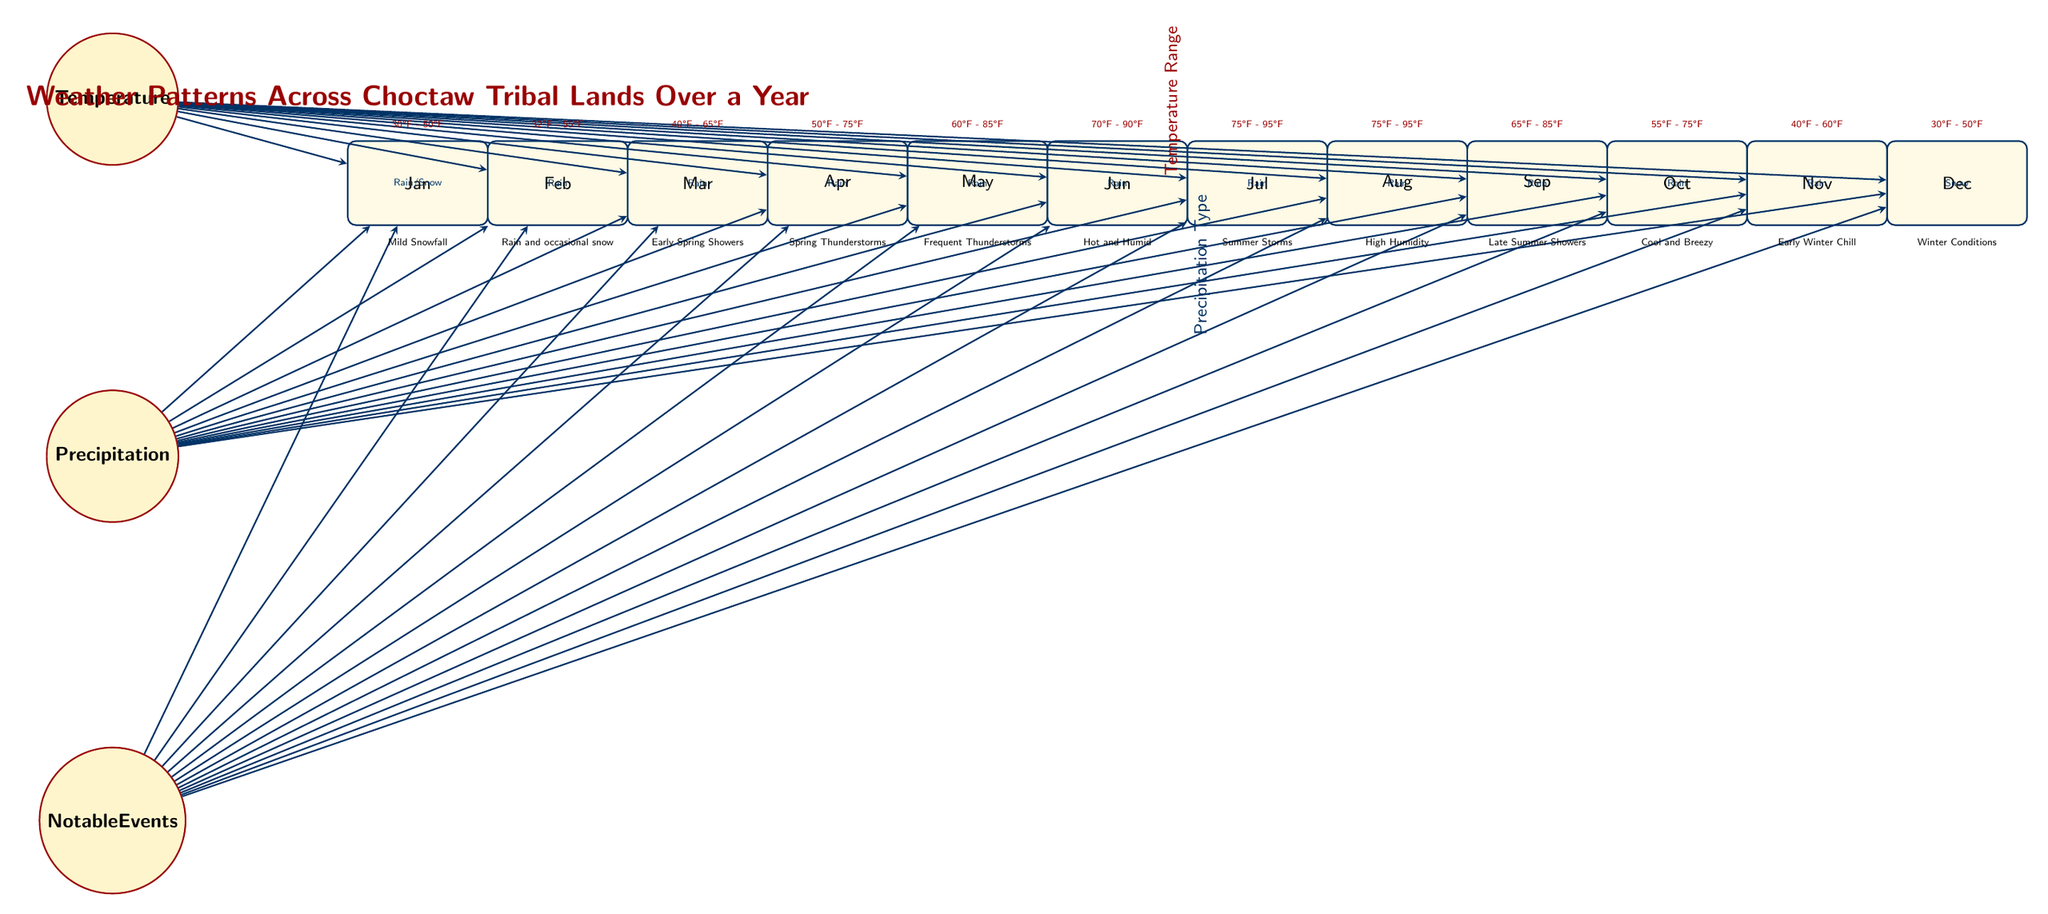What is the temperature range for July? To find the temperature range for July, locate the "July" node in the diagram and look at the information above it, which states "75°F - 95°F".
Answer: 75°F - 95°F How many months indicate "Rain" as precipitation type? Count the nodes that are connected to the precipitation node and check each month's precipitation type. All months except December indicate "Rain". There are 11 months total.
Answer: 11 Which month has "Early Spring Showers" as a notable event? To get the answer, find the month node for March and read the notable event below it, which specifies "Early Spring Showers".
Answer: March What is the notable weather event in December? Look at the "December" node in the diagram and find the notable event listed below it. It states "Winter Conditions".
Answer: Winter Conditions Which month experiences the highest temperature range? Review the temperature ranges displayed for each month. July and August both have a range of "75°F - 95°F", making them equal for the highest temperature range.
Answer: July and August In which month does "Frequent Thunderstorms" occur? Find the node for May in the diagram and check the notable event listed below it, which specifies "Frequent Thunderstorms".
Answer: May What type of precipitation is expected in November? Locate the "November" node and check the information in the center, which states "Rain".
Answer: Rain How many notable weather events are categorized under "Snow"? Check each month's notable event line and identify how many mention "Snow". Only December has this category, leading to one event.
Answer: 1 Which month has the lowest temperature range? Examine the temperature ranges in the diagram, noting that January has the lowest range of "30°F - 50°F".
Answer: January 